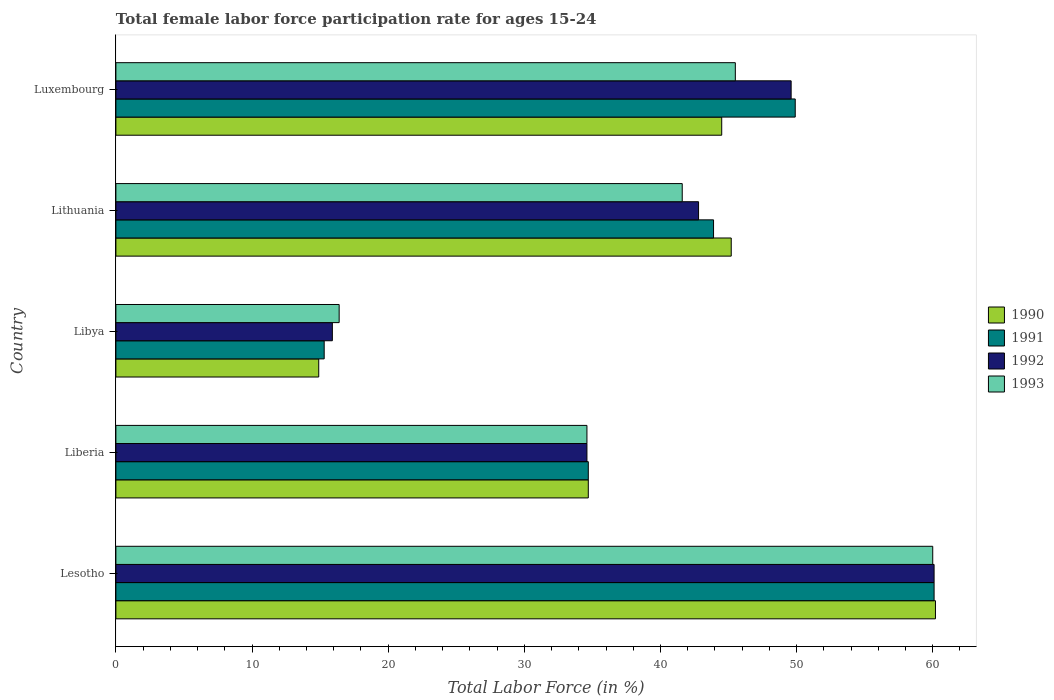Are the number of bars per tick equal to the number of legend labels?
Your answer should be compact. Yes. Are the number of bars on each tick of the Y-axis equal?
Provide a short and direct response. Yes. How many bars are there on the 2nd tick from the top?
Provide a succinct answer. 4. How many bars are there on the 3rd tick from the bottom?
Provide a succinct answer. 4. What is the label of the 2nd group of bars from the top?
Make the answer very short. Lithuania. What is the female labor force participation rate in 1992 in Libya?
Keep it short and to the point. 15.9. Across all countries, what is the maximum female labor force participation rate in 1993?
Ensure brevity in your answer.  60. Across all countries, what is the minimum female labor force participation rate in 1993?
Offer a very short reply. 16.4. In which country was the female labor force participation rate in 1991 maximum?
Keep it short and to the point. Lesotho. In which country was the female labor force participation rate in 1992 minimum?
Offer a very short reply. Libya. What is the total female labor force participation rate in 1990 in the graph?
Your answer should be very brief. 199.5. What is the average female labor force participation rate in 1992 per country?
Provide a short and direct response. 40.6. What is the difference between the female labor force participation rate in 1991 and female labor force participation rate in 1992 in Luxembourg?
Keep it short and to the point. 0.3. In how many countries, is the female labor force participation rate in 1993 greater than 12 %?
Keep it short and to the point. 5. What is the ratio of the female labor force participation rate in 1993 in Libya to that in Luxembourg?
Your answer should be compact. 0.36. Is the female labor force participation rate in 1993 in Libya less than that in Lithuania?
Your answer should be very brief. Yes. What is the difference between the highest and the second highest female labor force participation rate in 1990?
Ensure brevity in your answer.  15. What is the difference between the highest and the lowest female labor force participation rate in 1993?
Offer a terse response. 43.6. Is it the case that in every country, the sum of the female labor force participation rate in 1990 and female labor force participation rate in 1993 is greater than the sum of female labor force participation rate in 1992 and female labor force participation rate in 1991?
Offer a very short reply. No. What does the 1st bar from the top in Liberia represents?
Give a very brief answer. 1993. What does the 4th bar from the bottom in Libya represents?
Provide a succinct answer. 1993. How many bars are there?
Offer a terse response. 20. Are the values on the major ticks of X-axis written in scientific E-notation?
Offer a terse response. No. Does the graph contain any zero values?
Provide a short and direct response. No. Where does the legend appear in the graph?
Offer a very short reply. Center right. What is the title of the graph?
Provide a succinct answer. Total female labor force participation rate for ages 15-24. Does "1961" appear as one of the legend labels in the graph?
Provide a short and direct response. No. What is the label or title of the Y-axis?
Make the answer very short. Country. What is the Total Labor Force (in %) in 1990 in Lesotho?
Provide a succinct answer. 60.2. What is the Total Labor Force (in %) of 1991 in Lesotho?
Your answer should be compact. 60.1. What is the Total Labor Force (in %) in 1992 in Lesotho?
Your response must be concise. 60.1. What is the Total Labor Force (in %) of 1993 in Lesotho?
Offer a very short reply. 60. What is the Total Labor Force (in %) of 1990 in Liberia?
Keep it short and to the point. 34.7. What is the Total Labor Force (in %) of 1991 in Liberia?
Keep it short and to the point. 34.7. What is the Total Labor Force (in %) in 1992 in Liberia?
Keep it short and to the point. 34.6. What is the Total Labor Force (in %) in 1993 in Liberia?
Your answer should be very brief. 34.6. What is the Total Labor Force (in %) of 1990 in Libya?
Offer a very short reply. 14.9. What is the Total Labor Force (in %) in 1991 in Libya?
Ensure brevity in your answer.  15.3. What is the Total Labor Force (in %) in 1992 in Libya?
Provide a short and direct response. 15.9. What is the Total Labor Force (in %) of 1993 in Libya?
Give a very brief answer. 16.4. What is the Total Labor Force (in %) of 1990 in Lithuania?
Offer a very short reply. 45.2. What is the Total Labor Force (in %) of 1991 in Lithuania?
Offer a terse response. 43.9. What is the Total Labor Force (in %) of 1992 in Lithuania?
Your answer should be very brief. 42.8. What is the Total Labor Force (in %) in 1993 in Lithuania?
Ensure brevity in your answer.  41.6. What is the Total Labor Force (in %) in 1990 in Luxembourg?
Your answer should be compact. 44.5. What is the Total Labor Force (in %) in 1991 in Luxembourg?
Offer a terse response. 49.9. What is the Total Labor Force (in %) of 1992 in Luxembourg?
Offer a terse response. 49.6. What is the Total Labor Force (in %) of 1993 in Luxembourg?
Give a very brief answer. 45.5. Across all countries, what is the maximum Total Labor Force (in %) of 1990?
Ensure brevity in your answer.  60.2. Across all countries, what is the maximum Total Labor Force (in %) of 1991?
Provide a short and direct response. 60.1. Across all countries, what is the maximum Total Labor Force (in %) of 1992?
Your answer should be very brief. 60.1. Across all countries, what is the maximum Total Labor Force (in %) in 1993?
Keep it short and to the point. 60. Across all countries, what is the minimum Total Labor Force (in %) in 1990?
Provide a short and direct response. 14.9. Across all countries, what is the minimum Total Labor Force (in %) of 1991?
Your answer should be compact. 15.3. Across all countries, what is the minimum Total Labor Force (in %) of 1992?
Offer a terse response. 15.9. Across all countries, what is the minimum Total Labor Force (in %) in 1993?
Your answer should be very brief. 16.4. What is the total Total Labor Force (in %) of 1990 in the graph?
Keep it short and to the point. 199.5. What is the total Total Labor Force (in %) in 1991 in the graph?
Offer a very short reply. 203.9. What is the total Total Labor Force (in %) of 1992 in the graph?
Make the answer very short. 203. What is the total Total Labor Force (in %) in 1993 in the graph?
Make the answer very short. 198.1. What is the difference between the Total Labor Force (in %) in 1991 in Lesotho and that in Liberia?
Make the answer very short. 25.4. What is the difference between the Total Labor Force (in %) in 1993 in Lesotho and that in Liberia?
Offer a very short reply. 25.4. What is the difference between the Total Labor Force (in %) of 1990 in Lesotho and that in Libya?
Provide a short and direct response. 45.3. What is the difference between the Total Labor Force (in %) of 1991 in Lesotho and that in Libya?
Ensure brevity in your answer.  44.8. What is the difference between the Total Labor Force (in %) of 1992 in Lesotho and that in Libya?
Offer a very short reply. 44.2. What is the difference between the Total Labor Force (in %) in 1993 in Lesotho and that in Libya?
Ensure brevity in your answer.  43.6. What is the difference between the Total Labor Force (in %) in 1991 in Lesotho and that in Lithuania?
Give a very brief answer. 16.2. What is the difference between the Total Labor Force (in %) of 1993 in Lesotho and that in Lithuania?
Offer a terse response. 18.4. What is the difference between the Total Labor Force (in %) in 1991 in Lesotho and that in Luxembourg?
Offer a very short reply. 10.2. What is the difference between the Total Labor Force (in %) of 1993 in Lesotho and that in Luxembourg?
Give a very brief answer. 14.5. What is the difference between the Total Labor Force (in %) in 1990 in Liberia and that in Libya?
Your answer should be very brief. 19.8. What is the difference between the Total Labor Force (in %) in 1991 in Liberia and that in Libya?
Offer a very short reply. 19.4. What is the difference between the Total Labor Force (in %) of 1993 in Liberia and that in Libya?
Make the answer very short. 18.2. What is the difference between the Total Labor Force (in %) of 1990 in Liberia and that in Lithuania?
Offer a very short reply. -10.5. What is the difference between the Total Labor Force (in %) of 1991 in Liberia and that in Lithuania?
Offer a very short reply. -9.2. What is the difference between the Total Labor Force (in %) in 1990 in Liberia and that in Luxembourg?
Your response must be concise. -9.8. What is the difference between the Total Labor Force (in %) in 1991 in Liberia and that in Luxembourg?
Provide a succinct answer. -15.2. What is the difference between the Total Labor Force (in %) of 1992 in Liberia and that in Luxembourg?
Your response must be concise. -15. What is the difference between the Total Labor Force (in %) in 1990 in Libya and that in Lithuania?
Offer a very short reply. -30.3. What is the difference between the Total Labor Force (in %) of 1991 in Libya and that in Lithuania?
Offer a terse response. -28.6. What is the difference between the Total Labor Force (in %) in 1992 in Libya and that in Lithuania?
Your response must be concise. -26.9. What is the difference between the Total Labor Force (in %) of 1993 in Libya and that in Lithuania?
Provide a succinct answer. -25.2. What is the difference between the Total Labor Force (in %) of 1990 in Libya and that in Luxembourg?
Offer a terse response. -29.6. What is the difference between the Total Labor Force (in %) of 1991 in Libya and that in Luxembourg?
Your answer should be compact. -34.6. What is the difference between the Total Labor Force (in %) in 1992 in Libya and that in Luxembourg?
Give a very brief answer. -33.7. What is the difference between the Total Labor Force (in %) in 1993 in Libya and that in Luxembourg?
Give a very brief answer. -29.1. What is the difference between the Total Labor Force (in %) of 1990 in Lithuania and that in Luxembourg?
Your answer should be compact. 0.7. What is the difference between the Total Labor Force (in %) of 1991 in Lithuania and that in Luxembourg?
Your response must be concise. -6. What is the difference between the Total Labor Force (in %) in 1992 in Lithuania and that in Luxembourg?
Offer a very short reply. -6.8. What is the difference between the Total Labor Force (in %) in 1993 in Lithuania and that in Luxembourg?
Your answer should be compact. -3.9. What is the difference between the Total Labor Force (in %) in 1990 in Lesotho and the Total Labor Force (in %) in 1991 in Liberia?
Provide a short and direct response. 25.5. What is the difference between the Total Labor Force (in %) of 1990 in Lesotho and the Total Labor Force (in %) of 1992 in Liberia?
Your answer should be very brief. 25.6. What is the difference between the Total Labor Force (in %) of 1990 in Lesotho and the Total Labor Force (in %) of 1993 in Liberia?
Provide a short and direct response. 25.6. What is the difference between the Total Labor Force (in %) of 1991 in Lesotho and the Total Labor Force (in %) of 1992 in Liberia?
Your answer should be compact. 25.5. What is the difference between the Total Labor Force (in %) of 1991 in Lesotho and the Total Labor Force (in %) of 1993 in Liberia?
Give a very brief answer. 25.5. What is the difference between the Total Labor Force (in %) in 1992 in Lesotho and the Total Labor Force (in %) in 1993 in Liberia?
Give a very brief answer. 25.5. What is the difference between the Total Labor Force (in %) in 1990 in Lesotho and the Total Labor Force (in %) in 1991 in Libya?
Your answer should be compact. 44.9. What is the difference between the Total Labor Force (in %) of 1990 in Lesotho and the Total Labor Force (in %) of 1992 in Libya?
Your response must be concise. 44.3. What is the difference between the Total Labor Force (in %) of 1990 in Lesotho and the Total Labor Force (in %) of 1993 in Libya?
Your answer should be very brief. 43.8. What is the difference between the Total Labor Force (in %) of 1991 in Lesotho and the Total Labor Force (in %) of 1992 in Libya?
Keep it short and to the point. 44.2. What is the difference between the Total Labor Force (in %) in 1991 in Lesotho and the Total Labor Force (in %) in 1993 in Libya?
Offer a terse response. 43.7. What is the difference between the Total Labor Force (in %) in 1992 in Lesotho and the Total Labor Force (in %) in 1993 in Libya?
Keep it short and to the point. 43.7. What is the difference between the Total Labor Force (in %) of 1990 in Lesotho and the Total Labor Force (in %) of 1991 in Lithuania?
Provide a short and direct response. 16.3. What is the difference between the Total Labor Force (in %) of 1990 in Lesotho and the Total Labor Force (in %) of 1992 in Lithuania?
Offer a terse response. 17.4. What is the difference between the Total Labor Force (in %) of 1991 in Lesotho and the Total Labor Force (in %) of 1992 in Lithuania?
Your response must be concise. 17.3. What is the difference between the Total Labor Force (in %) in 1991 in Lesotho and the Total Labor Force (in %) in 1993 in Lithuania?
Your answer should be compact. 18.5. What is the difference between the Total Labor Force (in %) in 1992 in Lesotho and the Total Labor Force (in %) in 1993 in Lithuania?
Ensure brevity in your answer.  18.5. What is the difference between the Total Labor Force (in %) in 1990 in Lesotho and the Total Labor Force (in %) in 1992 in Luxembourg?
Make the answer very short. 10.6. What is the difference between the Total Labor Force (in %) of 1990 in Lesotho and the Total Labor Force (in %) of 1993 in Luxembourg?
Offer a very short reply. 14.7. What is the difference between the Total Labor Force (in %) of 1991 in Lesotho and the Total Labor Force (in %) of 1992 in Luxembourg?
Give a very brief answer. 10.5. What is the difference between the Total Labor Force (in %) of 1992 in Lesotho and the Total Labor Force (in %) of 1993 in Luxembourg?
Provide a short and direct response. 14.6. What is the difference between the Total Labor Force (in %) in 1990 in Liberia and the Total Labor Force (in %) in 1991 in Libya?
Your answer should be compact. 19.4. What is the difference between the Total Labor Force (in %) in 1990 in Liberia and the Total Labor Force (in %) in 1992 in Libya?
Keep it short and to the point. 18.8. What is the difference between the Total Labor Force (in %) of 1992 in Liberia and the Total Labor Force (in %) of 1993 in Libya?
Your answer should be very brief. 18.2. What is the difference between the Total Labor Force (in %) of 1991 in Liberia and the Total Labor Force (in %) of 1992 in Lithuania?
Offer a very short reply. -8.1. What is the difference between the Total Labor Force (in %) of 1991 in Liberia and the Total Labor Force (in %) of 1993 in Lithuania?
Your answer should be compact. -6.9. What is the difference between the Total Labor Force (in %) in 1990 in Liberia and the Total Labor Force (in %) in 1991 in Luxembourg?
Provide a short and direct response. -15.2. What is the difference between the Total Labor Force (in %) of 1990 in Liberia and the Total Labor Force (in %) of 1992 in Luxembourg?
Provide a succinct answer. -14.9. What is the difference between the Total Labor Force (in %) in 1991 in Liberia and the Total Labor Force (in %) in 1992 in Luxembourg?
Provide a short and direct response. -14.9. What is the difference between the Total Labor Force (in %) in 1990 in Libya and the Total Labor Force (in %) in 1992 in Lithuania?
Ensure brevity in your answer.  -27.9. What is the difference between the Total Labor Force (in %) of 1990 in Libya and the Total Labor Force (in %) of 1993 in Lithuania?
Offer a terse response. -26.7. What is the difference between the Total Labor Force (in %) of 1991 in Libya and the Total Labor Force (in %) of 1992 in Lithuania?
Offer a very short reply. -27.5. What is the difference between the Total Labor Force (in %) of 1991 in Libya and the Total Labor Force (in %) of 1993 in Lithuania?
Your answer should be very brief. -26.3. What is the difference between the Total Labor Force (in %) of 1992 in Libya and the Total Labor Force (in %) of 1993 in Lithuania?
Make the answer very short. -25.7. What is the difference between the Total Labor Force (in %) of 1990 in Libya and the Total Labor Force (in %) of 1991 in Luxembourg?
Give a very brief answer. -35. What is the difference between the Total Labor Force (in %) in 1990 in Libya and the Total Labor Force (in %) in 1992 in Luxembourg?
Keep it short and to the point. -34.7. What is the difference between the Total Labor Force (in %) of 1990 in Libya and the Total Labor Force (in %) of 1993 in Luxembourg?
Your answer should be very brief. -30.6. What is the difference between the Total Labor Force (in %) of 1991 in Libya and the Total Labor Force (in %) of 1992 in Luxembourg?
Provide a short and direct response. -34.3. What is the difference between the Total Labor Force (in %) in 1991 in Libya and the Total Labor Force (in %) in 1993 in Luxembourg?
Provide a short and direct response. -30.2. What is the difference between the Total Labor Force (in %) in 1992 in Libya and the Total Labor Force (in %) in 1993 in Luxembourg?
Provide a succinct answer. -29.6. What is the difference between the Total Labor Force (in %) of 1991 in Lithuania and the Total Labor Force (in %) of 1992 in Luxembourg?
Make the answer very short. -5.7. What is the difference between the Total Labor Force (in %) in 1991 in Lithuania and the Total Labor Force (in %) in 1993 in Luxembourg?
Offer a terse response. -1.6. What is the difference between the Total Labor Force (in %) of 1992 in Lithuania and the Total Labor Force (in %) of 1993 in Luxembourg?
Your response must be concise. -2.7. What is the average Total Labor Force (in %) of 1990 per country?
Provide a succinct answer. 39.9. What is the average Total Labor Force (in %) in 1991 per country?
Provide a short and direct response. 40.78. What is the average Total Labor Force (in %) in 1992 per country?
Provide a succinct answer. 40.6. What is the average Total Labor Force (in %) of 1993 per country?
Provide a short and direct response. 39.62. What is the difference between the Total Labor Force (in %) in 1990 and Total Labor Force (in %) in 1992 in Lesotho?
Ensure brevity in your answer.  0.1. What is the difference between the Total Labor Force (in %) in 1990 and Total Labor Force (in %) in 1993 in Lesotho?
Give a very brief answer. 0.2. What is the difference between the Total Labor Force (in %) in 1990 and Total Labor Force (in %) in 1991 in Liberia?
Keep it short and to the point. 0. What is the difference between the Total Labor Force (in %) of 1990 and Total Labor Force (in %) of 1992 in Liberia?
Offer a terse response. 0.1. What is the difference between the Total Labor Force (in %) of 1990 and Total Labor Force (in %) of 1993 in Liberia?
Your answer should be compact. 0.1. What is the difference between the Total Labor Force (in %) in 1992 and Total Labor Force (in %) in 1993 in Liberia?
Your answer should be very brief. 0. What is the difference between the Total Labor Force (in %) of 1990 and Total Labor Force (in %) of 1991 in Lithuania?
Your answer should be compact. 1.3. What is the difference between the Total Labor Force (in %) of 1990 and Total Labor Force (in %) of 1993 in Luxembourg?
Keep it short and to the point. -1. What is the difference between the Total Labor Force (in %) in 1991 and Total Labor Force (in %) in 1992 in Luxembourg?
Offer a terse response. 0.3. What is the difference between the Total Labor Force (in %) of 1991 and Total Labor Force (in %) of 1993 in Luxembourg?
Keep it short and to the point. 4.4. What is the difference between the Total Labor Force (in %) of 1992 and Total Labor Force (in %) of 1993 in Luxembourg?
Provide a succinct answer. 4.1. What is the ratio of the Total Labor Force (in %) of 1990 in Lesotho to that in Liberia?
Your answer should be very brief. 1.73. What is the ratio of the Total Labor Force (in %) of 1991 in Lesotho to that in Liberia?
Provide a succinct answer. 1.73. What is the ratio of the Total Labor Force (in %) in 1992 in Lesotho to that in Liberia?
Offer a terse response. 1.74. What is the ratio of the Total Labor Force (in %) in 1993 in Lesotho to that in Liberia?
Provide a succinct answer. 1.73. What is the ratio of the Total Labor Force (in %) of 1990 in Lesotho to that in Libya?
Make the answer very short. 4.04. What is the ratio of the Total Labor Force (in %) in 1991 in Lesotho to that in Libya?
Make the answer very short. 3.93. What is the ratio of the Total Labor Force (in %) of 1992 in Lesotho to that in Libya?
Ensure brevity in your answer.  3.78. What is the ratio of the Total Labor Force (in %) of 1993 in Lesotho to that in Libya?
Your answer should be very brief. 3.66. What is the ratio of the Total Labor Force (in %) of 1990 in Lesotho to that in Lithuania?
Provide a succinct answer. 1.33. What is the ratio of the Total Labor Force (in %) of 1991 in Lesotho to that in Lithuania?
Offer a very short reply. 1.37. What is the ratio of the Total Labor Force (in %) of 1992 in Lesotho to that in Lithuania?
Offer a very short reply. 1.4. What is the ratio of the Total Labor Force (in %) in 1993 in Lesotho to that in Lithuania?
Your answer should be very brief. 1.44. What is the ratio of the Total Labor Force (in %) of 1990 in Lesotho to that in Luxembourg?
Your answer should be compact. 1.35. What is the ratio of the Total Labor Force (in %) in 1991 in Lesotho to that in Luxembourg?
Provide a succinct answer. 1.2. What is the ratio of the Total Labor Force (in %) in 1992 in Lesotho to that in Luxembourg?
Keep it short and to the point. 1.21. What is the ratio of the Total Labor Force (in %) in 1993 in Lesotho to that in Luxembourg?
Ensure brevity in your answer.  1.32. What is the ratio of the Total Labor Force (in %) of 1990 in Liberia to that in Libya?
Make the answer very short. 2.33. What is the ratio of the Total Labor Force (in %) in 1991 in Liberia to that in Libya?
Provide a short and direct response. 2.27. What is the ratio of the Total Labor Force (in %) in 1992 in Liberia to that in Libya?
Offer a terse response. 2.18. What is the ratio of the Total Labor Force (in %) in 1993 in Liberia to that in Libya?
Your answer should be very brief. 2.11. What is the ratio of the Total Labor Force (in %) in 1990 in Liberia to that in Lithuania?
Your answer should be compact. 0.77. What is the ratio of the Total Labor Force (in %) in 1991 in Liberia to that in Lithuania?
Ensure brevity in your answer.  0.79. What is the ratio of the Total Labor Force (in %) in 1992 in Liberia to that in Lithuania?
Provide a succinct answer. 0.81. What is the ratio of the Total Labor Force (in %) of 1993 in Liberia to that in Lithuania?
Your answer should be compact. 0.83. What is the ratio of the Total Labor Force (in %) of 1990 in Liberia to that in Luxembourg?
Provide a succinct answer. 0.78. What is the ratio of the Total Labor Force (in %) in 1991 in Liberia to that in Luxembourg?
Provide a short and direct response. 0.7. What is the ratio of the Total Labor Force (in %) in 1992 in Liberia to that in Luxembourg?
Offer a very short reply. 0.7. What is the ratio of the Total Labor Force (in %) of 1993 in Liberia to that in Luxembourg?
Offer a terse response. 0.76. What is the ratio of the Total Labor Force (in %) in 1990 in Libya to that in Lithuania?
Give a very brief answer. 0.33. What is the ratio of the Total Labor Force (in %) of 1991 in Libya to that in Lithuania?
Offer a terse response. 0.35. What is the ratio of the Total Labor Force (in %) in 1992 in Libya to that in Lithuania?
Your response must be concise. 0.37. What is the ratio of the Total Labor Force (in %) in 1993 in Libya to that in Lithuania?
Your answer should be compact. 0.39. What is the ratio of the Total Labor Force (in %) of 1990 in Libya to that in Luxembourg?
Provide a succinct answer. 0.33. What is the ratio of the Total Labor Force (in %) in 1991 in Libya to that in Luxembourg?
Keep it short and to the point. 0.31. What is the ratio of the Total Labor Force (in %) in 1992 in Libya to that in Luxembourg?
Keep it short and to the point. 0.32. What is the ratio of the Total Labor Force (in %) in 1993 in Libya to that in Luxembourg?
Your answer should be compact. 0.36. What is the ratio of the Total Labor Force (in %) in 1990 in Lithuania to that in Luxembourg?
Offer a terse response. 1.02. What is the ratio of the Total Labor Force (in %) in 1991 in Lithuania to that in Luxembourg?
Provide a succinct answer. 0.88. What is the ratio of the Total Labor Force (in %) of 1992 in Lithuania to that in Luxembourg?
Offer a terse response. 0.86. What is the ratio of the Total Labor Force (in %) in 1993 in Lithuania to that in Luxembourg?
Provide a succinct answer. 0.91. What is the difference between the highest and the second highest Total Labor Force (in %) in 1991?
Your answer should be very brief. 10.2. What is the difference between the highest and the second highest Total Labor Force (in %) of 1992?
Keep it short and to the point. 10.5. What is the difference between the highest and the second highest Total Labor Force (in %) of 1993?
Make the answer very short. 14.5. What is the difference between the highest and the lowest Total Labor Force (in %) of 1990?
Give a very brief answer. 45.3. What is the difference between the highest and the lowest Total Labor Force (in %) in 1991?
Offer a very short reply. 44.8. What is the difference between the highest and the lowest Total Labor Force (in %) in 1992?
Keep it short and to the point. 44.2. What is the difference between the highest and the lowest Total Labor Force (in %) of 1993?
Keep it short and to the point. 43.6. 